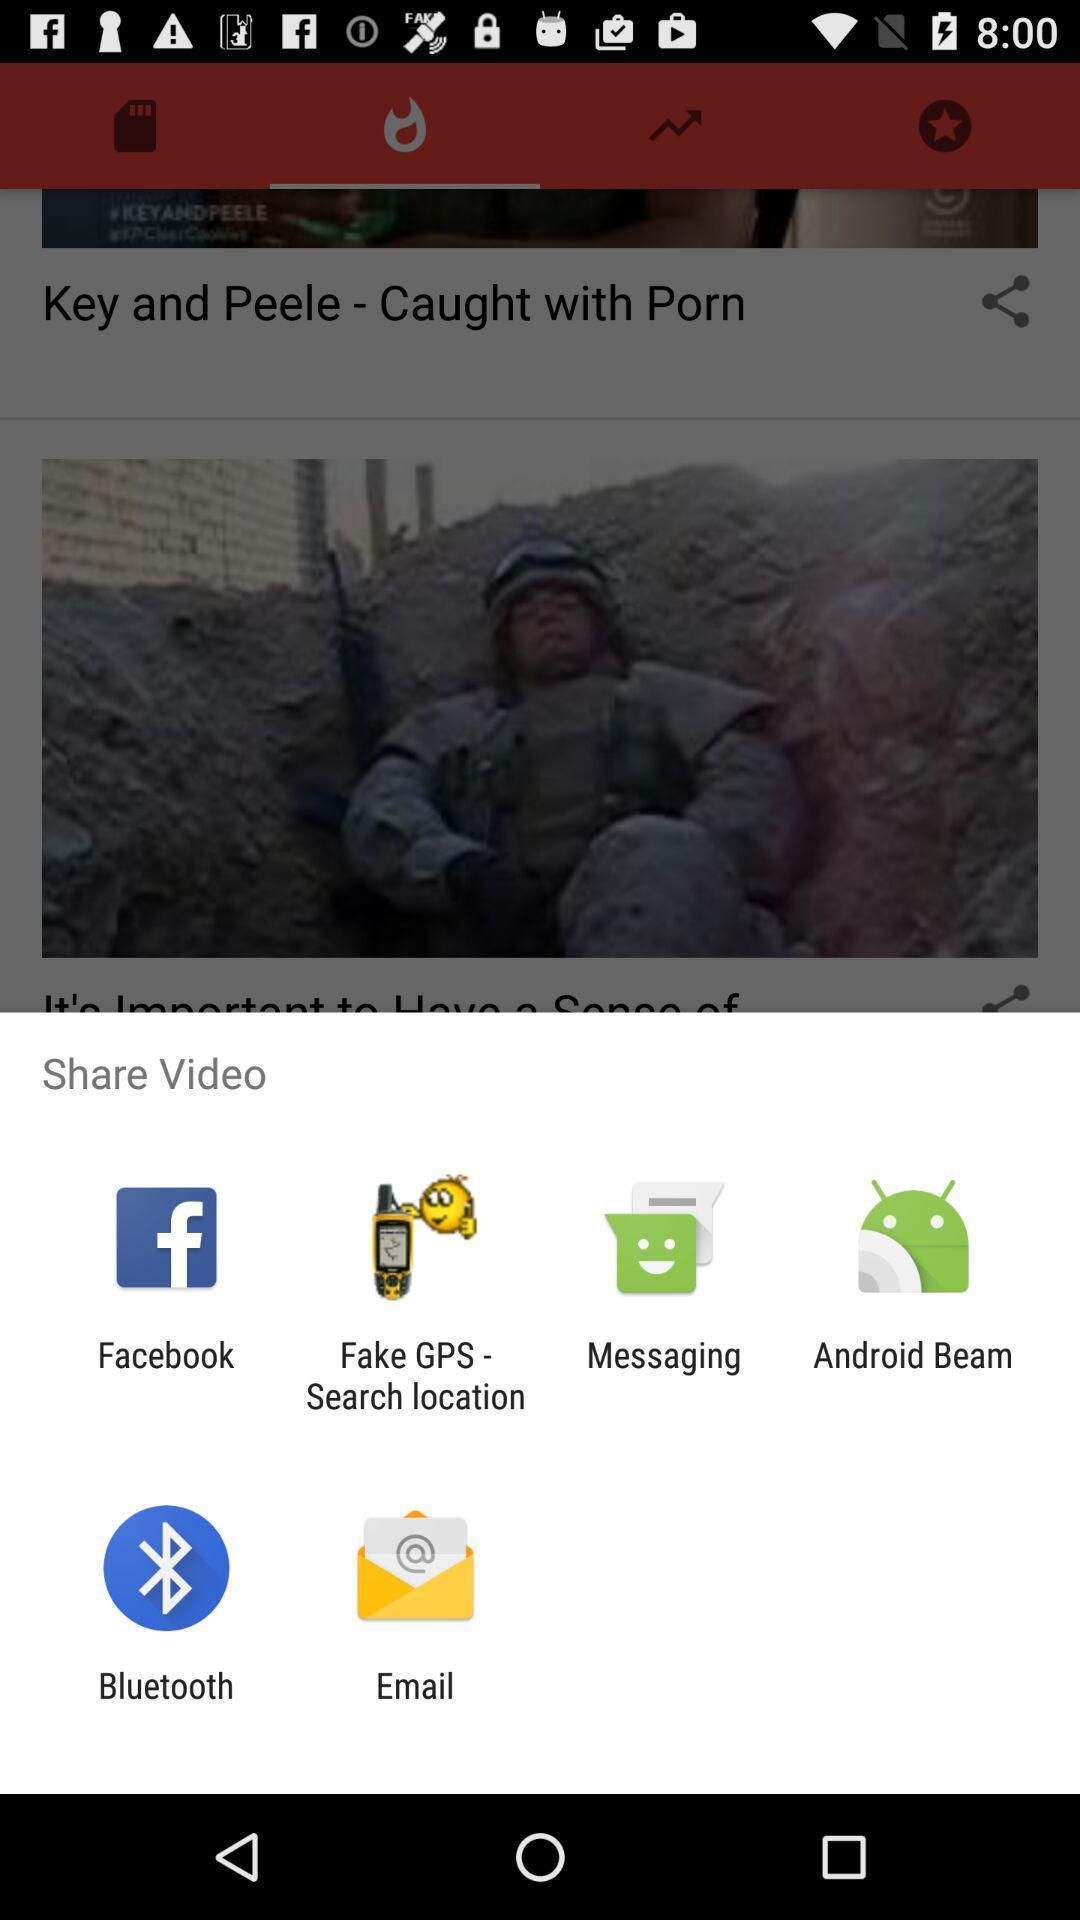Please provide a description for this image. Pop-up showing various share options. 